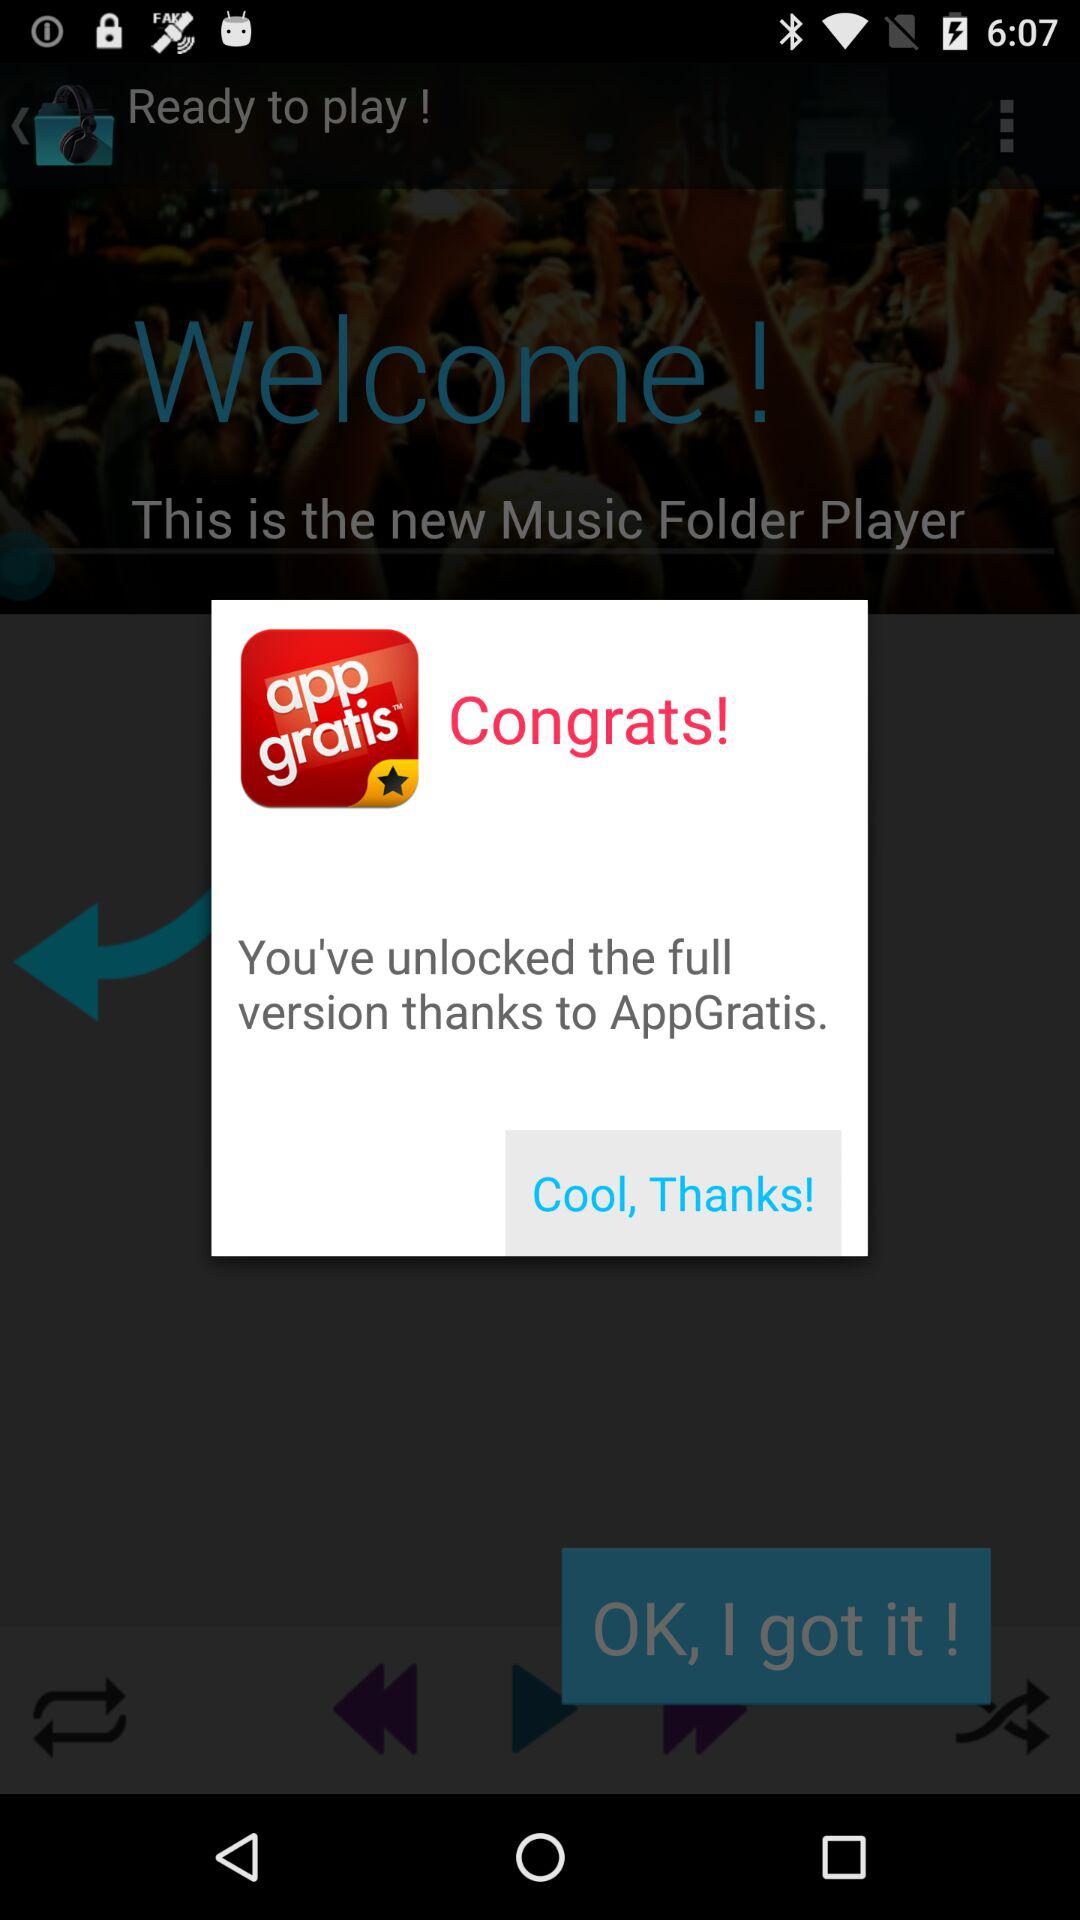How long is the audio track?
When the provided information is insufficient, respond with <no answer>. <no answer> 